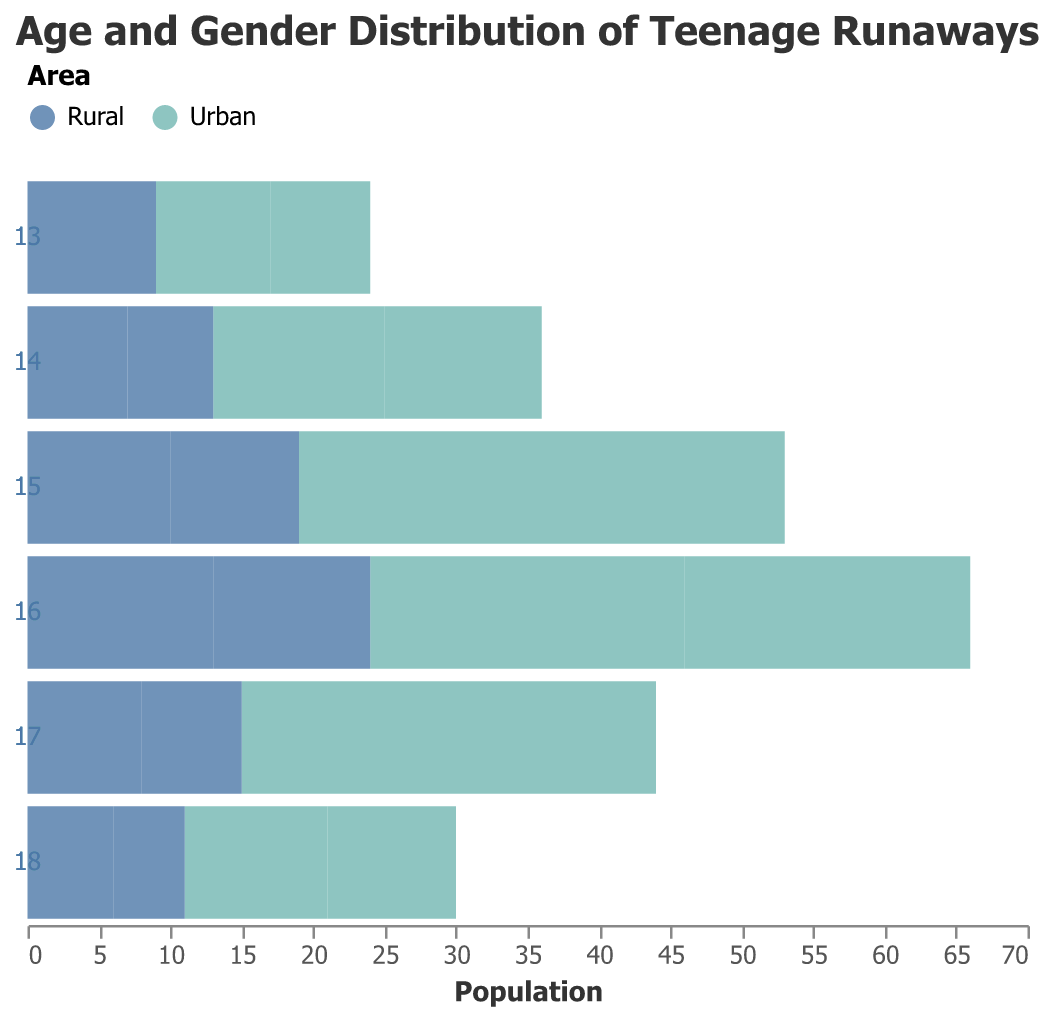How many male runaways aged 15 are there in rural areas? The chart shows that the value for male runaways aged 15 in rural areas is -10. Despite the negative sign (which indicates the direction on the pyramid), the number of male runaways is 10.
Answer: 10 Which gender is more prevalent among 14-year-old runaways in urban areas? For age 14 in urban areas, the graph shows -12 for males and 11 for females. The positive number for females (11) is greater than the absolute value for males (-12), indicating that female runaways are more prevalent for this age and area.
Answer: Female What is the total number of runaways aged 16 in rural areas for both genders combined? For rural areas at age 16, the values are -13 for males and 11 for females. Summing the absolute values of these numbers gives 13 + 11.
Answer: 24 Who has the highest number of runaways, rural or urban males aged 16? Comparing the absolute values for age 16, urban males are -22 while rural males are -13. 22 is greater than 13, meaning urban males aged 16 have more runaways.
Answer: Urban males What is the average number of runaways aged 17 for females in both urban and rural areas? For age 17, the value for urban females is 14 and for rural females, it is 7. To find the average: (14 + 7)/2 = 21/2.
Answer: 10.5 Which age group has the least female runaways in rural areas? The values for female runaways in rural areas by age are:
- Age 13: 4
- Age 14: 6
- Age 15: 9
- Age 16: 11
- Age 17: 7
- Age 18: 5
The smallest number is 4 for age 13.
Answer: 13 